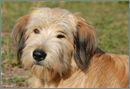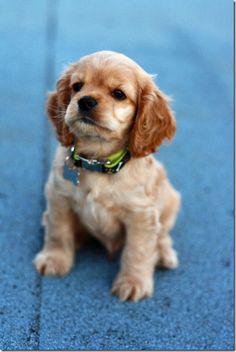The first image is the image on the left, the second image is the image on the right. Considering the images on both sides, is "The right image contains exactly three dogs." valid? Answer yes or no. No. 